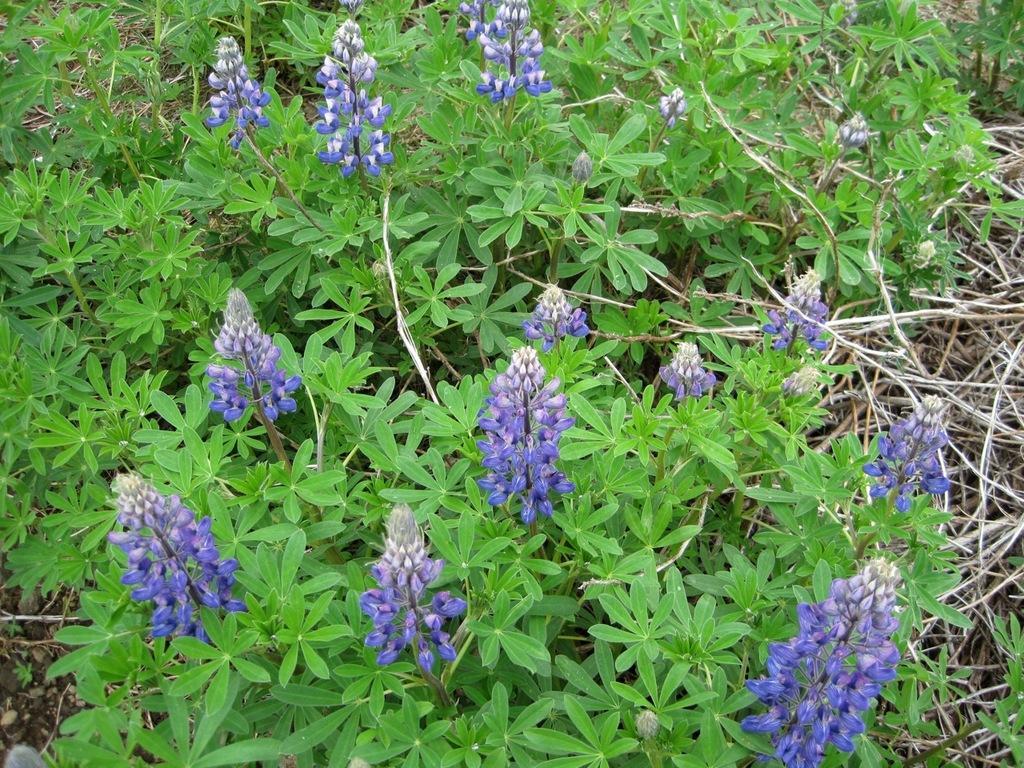Please provide a concise description of this image. In this picture we can see a few violet color flowers, plants and twigs on the right side. 